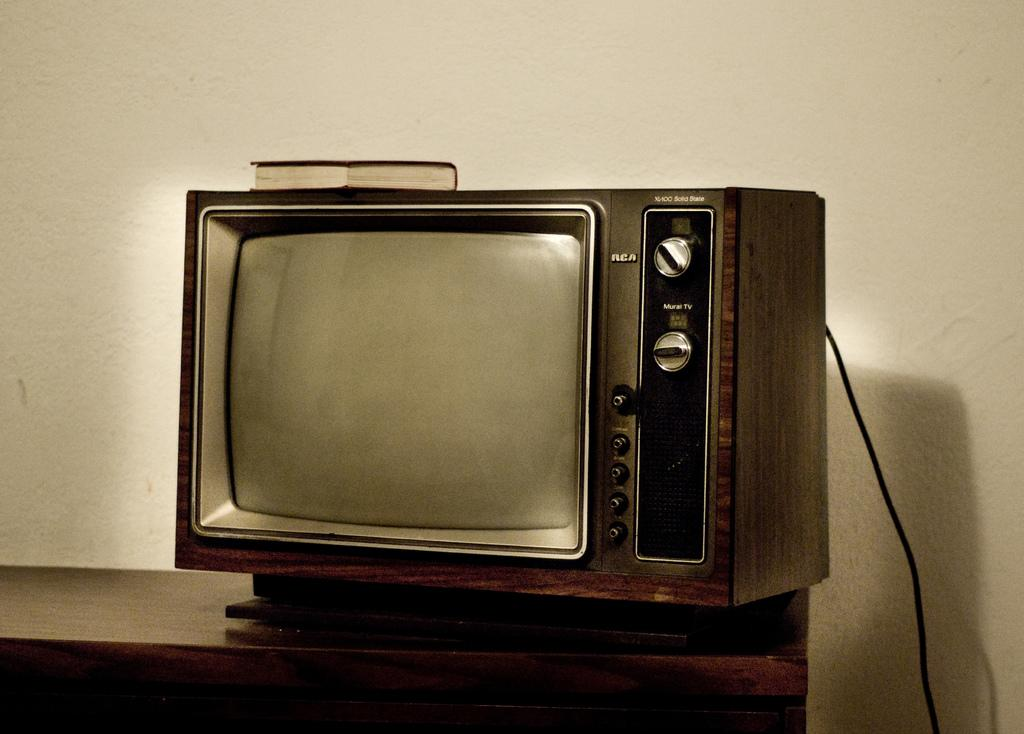<image>
Provide a brief description of the given image. An old RCA television sitting on top of a dresser 